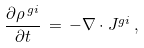<formula> <loc_0><loc_0><loc_500><loc_500>\frac { \partial \rho ^ { \, g i } } { \partial t } \, = \, - \nabla \cdot { J } ^ { g i } \, ,</formula> 